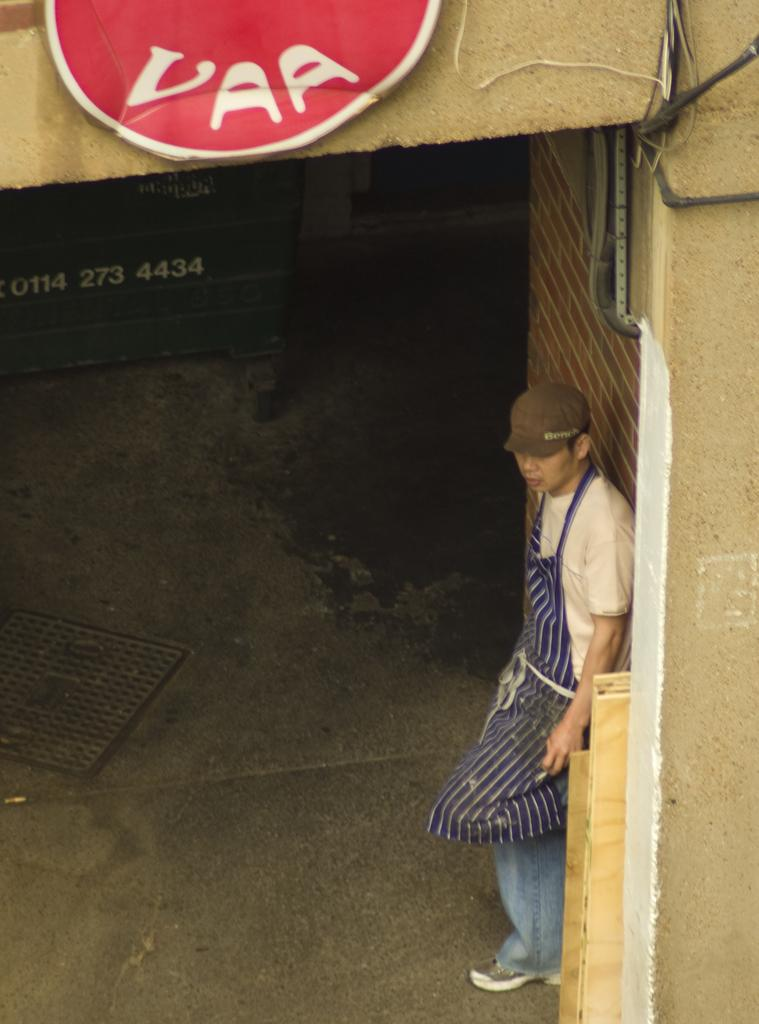What is the position of the man in the image? The man is standing on the right side of the image. What is the man wearing on his head? The man is wearing a cap. What is the man wearing on his body? The man is wearing an apron. What is located at the top of the image? There is a board at the top of the image. What type of structure can be seen in the image? There is a wall visible in the image. What type of humor is the man telling in the image? There is no indication of humor or any conversation in the image; the man is simply standing with a cap and apron. 